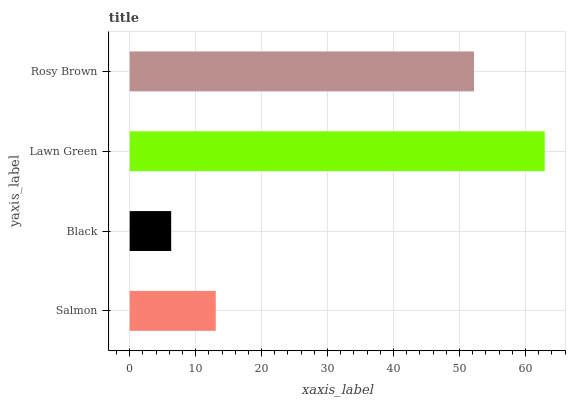Is Black the minimum?
Answer yes or no. Yes. Is Lawn Green the maximum?
Answer yes or no. Yes. Is Lawn Green the minimum?
Answer yes or no. No. Is Black the maximum?
Answer yes or no. No. Is Lawn Green greater than Black?
Answer yes or no. Yes. Is Black less than Lawn Green?
Answer yes or no. Yes. Is Black greater than Lawn Green?
Answer yes or no. No. Is Lawn Green less than Black?
Answer yes or no. No. Is Rosy Brown the high median?
Answer yes or no. Yes. Is Salmon the low median?
Answer yes or no. Yes. Is Salmon the high median?
Answer yes or no. No. Is Lawn Green the low median?
Answer yes or no. No. 